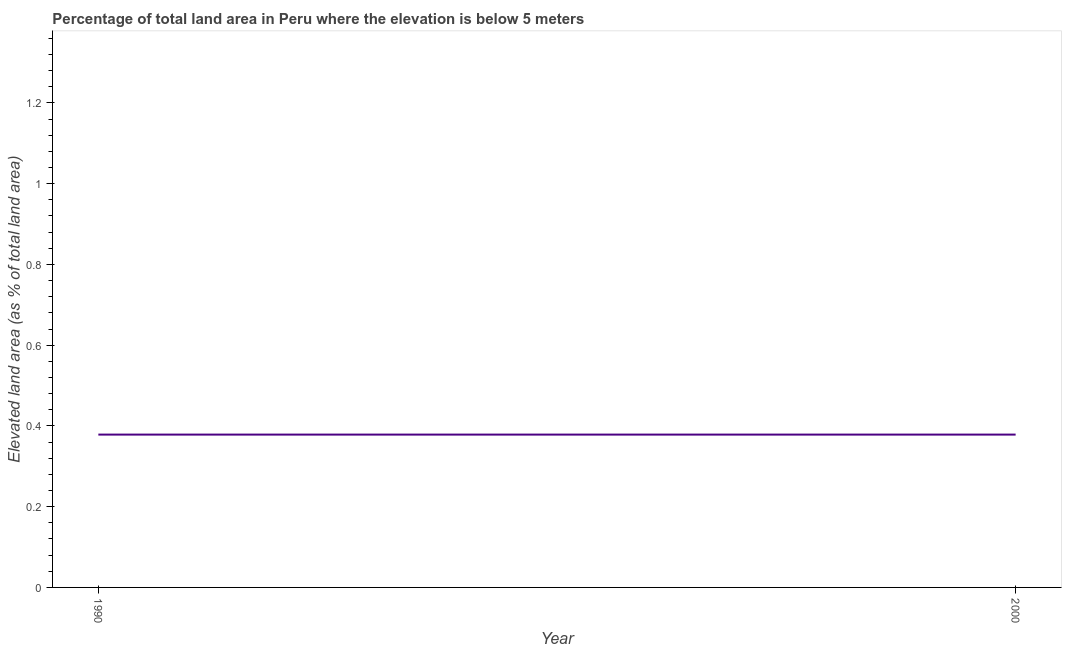What is the total elevated land area in 2000?
Make the answer very short. 0.38. Across all years, what is the maximum total elevated land area?
Your answer should be compact. 0.38. Across all years, what is the minimum total elevated land area?
Ensure brevity in your answer.  0.38. In which year was the total elevated land area maximum?
Make the answer very short. 1990. In which year was the total elevated land area minimum?
Your answer should be very brief. 1990. What is the sum of the total elevated land area?
Provide a short and direct response. 0.76. What is the difference between the total elevated land area in 1990 and 2000?
Give a very brief answer. 0. What is the average total elevated land area per year?
Offer a very short reply. 0.38. What is the median total elevated land area?
Ensure brevity in your answer.  0.38. Do a majority of the years between 1990 and 2000 (inclusive) have total elevated land area greater than 0.52 %?
Offer a terse response. No. In how many years, is the total elevated land area greater than the average total elevated land area taken over all years?
Offer a very short reply. 0. Does the total elevated land area monotonically increase over the years?
Provide a short and direct response. No. What is the difference between two consecutive major ticks on the Y-axis?
Ensure brevity in your answer.  0.2. Are the values on the major ticks of Y-axis written in scientific E-notation?
Provide a short and direct response. No. Does the graph contain any zero values?
Your response must be concise. No. Does the graph contain grids?
Give a very brief answer. No. What is the title of the graph?
Provide a succinct answer. Percentage of total land area in Peru where the elevation is below 5 meters. What is the label or title of the X-axis?
Give a very brief answer. Year. What is the label or title of the Y-axis?
Provide a succinct answer. Elevated land area (as % of total land area). What is the Elevated land area (as % of total land area) of 1990?
Provide a succinct answer. 0.38. What is the Elevated land area (as % of total land area) of 2000?
Your answer should be compact. 0.38. What is the difference between the Elevated land area (as % of total land area) in 1990 and 2000?
Provide a succinct answer. 0. What is the ratio of the Elevated land area (as % of total land area) in 1990 to that in 2000?
Provide a succinct answer. 1. 